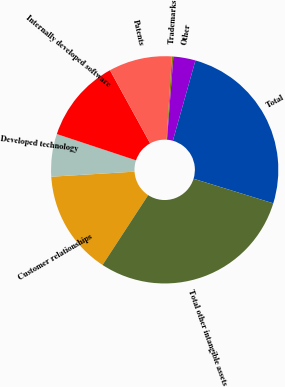Convert chart to OTSL. <chart><loc_0><loc_0><loc_500><loc_500><pie_chart><fcel>Customer relationships<fcel>Developed technology<fcel>Internally developed software<fcel>Patents<fcel>Trademarks<fcel>Other<fcel>Total<fcel>Total other intangible assets<nl><fcel>14.83%<fcel>6.06%<fcel>11.91%<fcel>8.99%<fcel>0.22%<fcel>3.14%<fcel>25.4%<fcel>29.44%<nl></chart> 